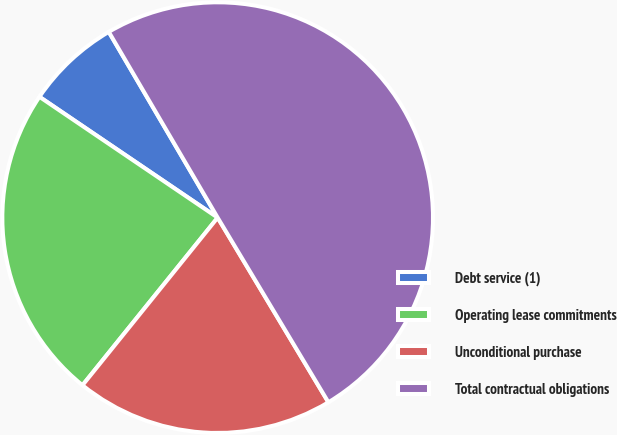<chart> <loc_0><loc_0><loc_500><loc_500><pie_chart><fcel>Debt service (1)<fcel>Operating lease commitments<fcel>Unconditional purchase<fcel>Total contractual obligations<nl><fcel>7.08%<fcel>23.68%<fcel>19.4%<fcel>49.84%<nl></chart> 